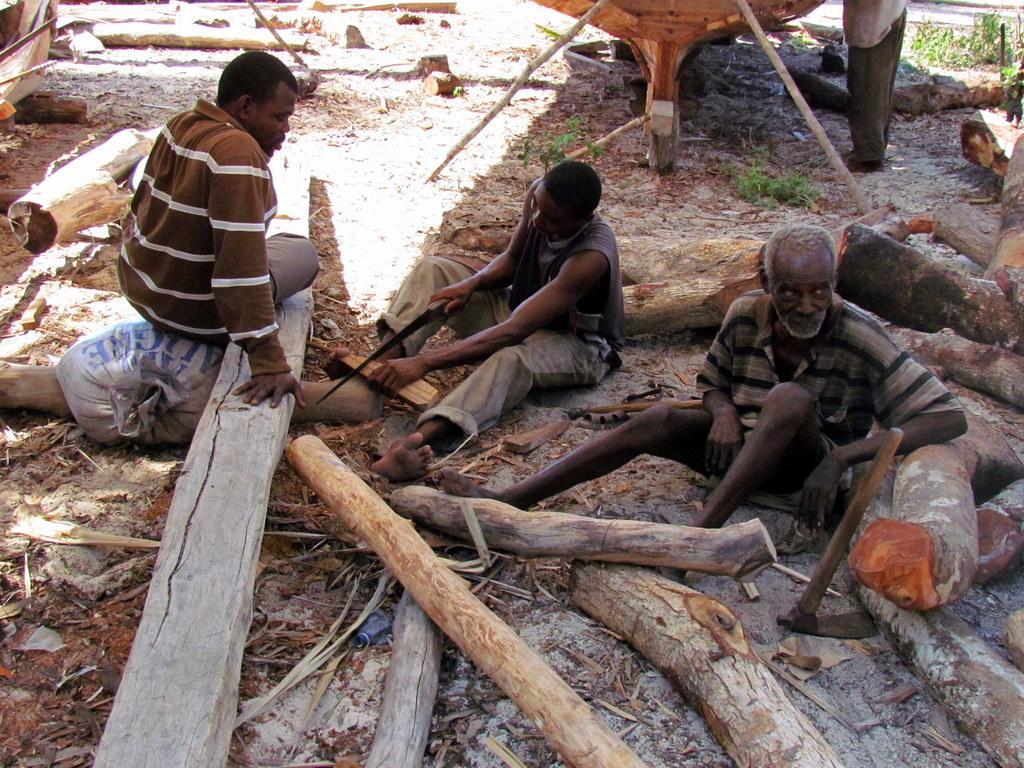Can you describe this image briefly? In this picture we observe three people are sitting and cutting the trees. 